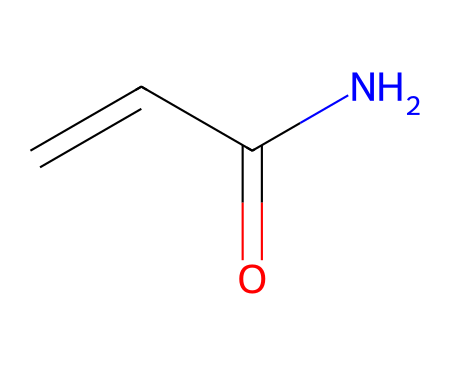What is the total number of carbon atoms in acrylamide? From the SMILES representation, C=CC(=O)N, we can see there are three carbon atoms represented by the three "C" symbols.
Answer: 3 How many nitrogen atoms are present in the structure? The SMILES notation includes one "N," indicating there is one nitrogen atom in acrylamide.
Answer: 1 What is the functional group present in acrylamide? By analyzing the SMILES structure, the presence of the "C(=O)N" indicates that acrylamide contains an amide functional group.
Answer: amide Is acrylamide a monomer or polymer? Acrylamide is defined as a monomer since it can polymerize into polyacrylamide.
Answer: monomer What is the characteristic bond type present in the carbonyl (C=O) part of acrylamide? The "C=O" notation shows that a double bond exists between a carbon atom and an oxygen atom, characteristic of carbonyl groups.
Answer: double bond Why is acrylamide considered hazardous in food processing? Acrylamide can form during high-temperature cooking processes of certain foods, leading to its classification as a potential carcinogen.
Answer: carcinogen 